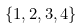Convert formula to latex. <formula><loc_0><loc_0><loc_500><loc_500>\{ 1 , 2 , 3 , 4 \}</formula> 